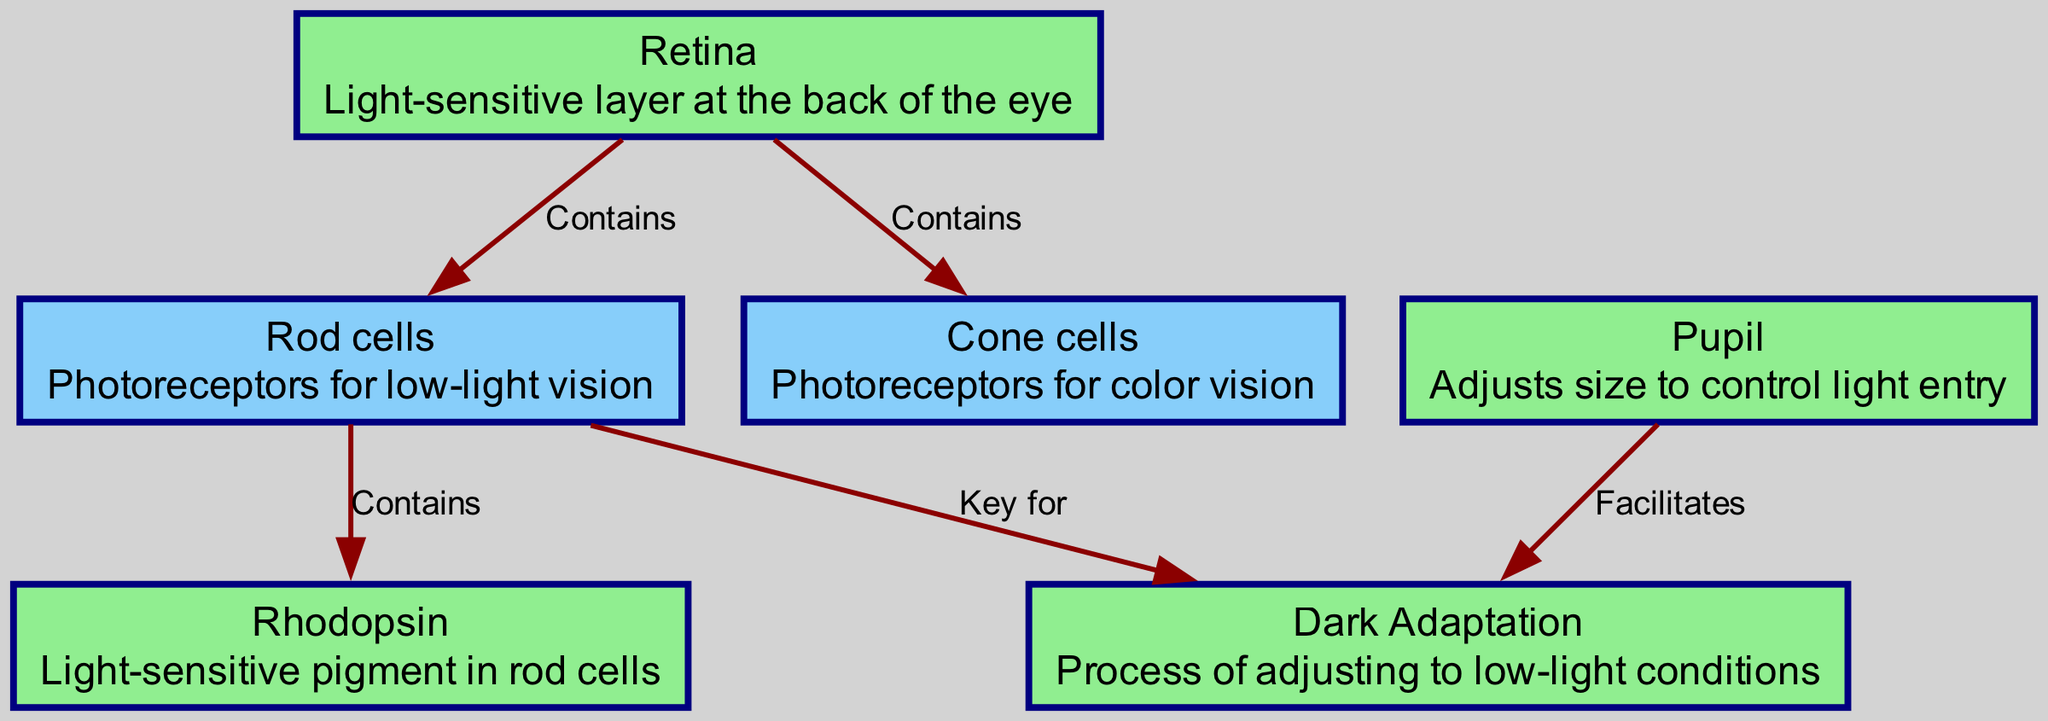What is the light-sensitive layer at the back of the eye? The diagram identifies the "Retina" as the light-sensitive layer at the back of the eye. This information can be found directly in the node description for 'retina'.
Answer: Retina How many types of photoreceptor cells are present in the retina? The diagram shows two types of photoreceptors: "Rod cells" and "Cone cells." This is evident from the two nodes connected to the 'retina' node in the graph.
Answer: Two Which photoreceptor is responsible for low-light vision? The diagram indicates that the "Rod cells" are the photoreceptors for low-light vision. This can be found in the description for the 'rods' node.
Answer: Rod cells What pigment is contained in rod cells? According to the diagram, "Rhodopsin" is the light-sensitive pigment found in rod cells. This is described in the node for 'rhodopsin'.
Answer: Rhodopsin How does the pupil affect dark adaptation? The diagram states that the "Pupil" facilitates the process of "Dark Adaptation." To understand this, one must look at the connection between the 'pupil' and 'darkAdaptation' nodes.
Answer: Facilitates Which cells are key for dark adaptation? The diagram shows that "Rod cells" are key for dark adaptation, as indicated by the connection from the 'rods' node to the 'darkAdaptation' node.
Answer: Rod cells What is the process of adjusting to low-light conditions called? The diagram defines "Dark Adaptation" as the process of adjusting to low-light conditions. This is directly mentioned in the 'darkAdaptation' node description.
Answer: Dark Adaptation What adjusts size to control light entry into the eye? The node labeled "Pupil" is responsible for adjusting size to control light entry, as described in its definition.
Answer: Pupil How many edges connect the retina to other structures? There are four edges that connect the 'retina' node to other structures, specifically to 'rods' and 'cones'. Counting the edges shows this relationship.
Answer: Four 